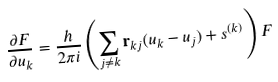<formula> <loc_0><loc_0><loc_500><loc_500>\frac { \partial F } { \partial u _ { k } } = \frac { h } { 2 \pi i } \left ( \sum _ { j \ne k } { \mathbf r } _ { k j } ( u _ { k } - u _ { j } ) + s ^ { ( k ) } \right ) F</formula> 